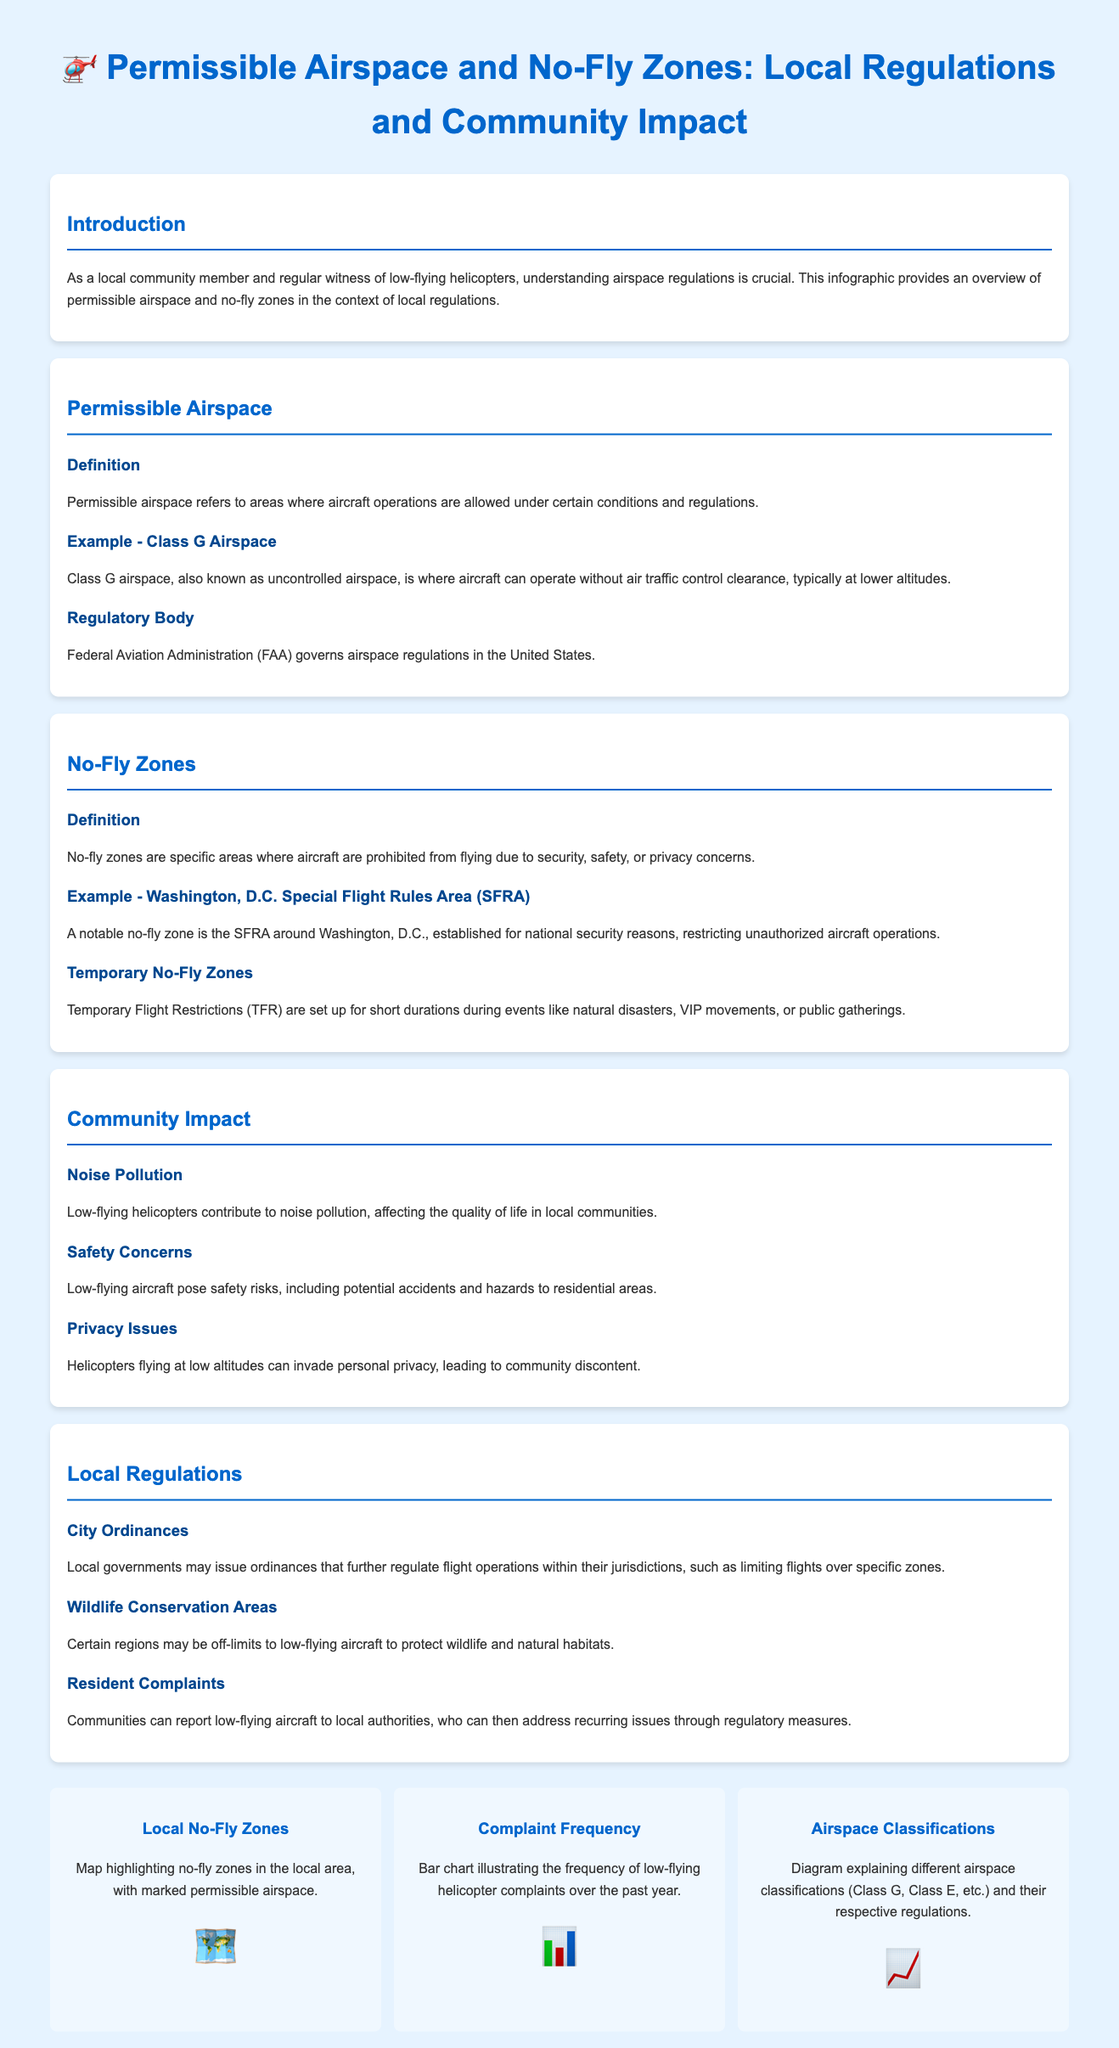What is permissible airspace? Permissible airspace refers to areas where aircraft operations are allowed under certain conditions and regulations.
Answer: Areas where aircraft operations are allowed What is an example of a no-fly zone? A notable no-fly zone is the SFRA around Washington, D.C., established for national security reasons, restricting unauthorized aircraft operations.
Answer: SFRA around Washington, D.C Which regulatory body governs airspace regulations in the United States? The Federal Aviation Administration (FAA) governs airspace regulations in the United States.
Answer: Federal Aviation Administration (FAA) What is one impact of low-flying helicopters on communities? Low-flying helicopters contribute to noise pollution, affecting the quality of life in local communities.
Answer: Noise pollution How can local residents address issues with low-flying helicopters? Communities can report low-flying aircraft to local authorities, who can then address recurring issues through regulatory measures.
Answer: Report to local authorities What does TFR stand for in the context of airspace? Temporary Flight Restrictions are set up for short durations during events like natural disasters.
Answer: Temporary Flight Restrictions What is the primary concern of low-flying aircraft regarding safety? Low-flying aircraft pose safety risks, including potential accidents and hazards to residential areas.
Answer: Safety risks Which visual item illustrates the frequency of low-flying helicopter complaints? The bar chart illustrating the frequency of low-flying helicopter complaints over the past year.
Answer: Bar chart illustrating complaint frequency What type of aircraft can operate without air traffic control in Class G airspace? Aircraft can operate without air traffic control clearance, typically at lower altitudes.
Answer: Aircraft without air traffic control clearance 